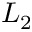Convert formula to latex. <formula><loc_0><loc_0><loc_500><loc_500>L _ { 2 }</formula> 